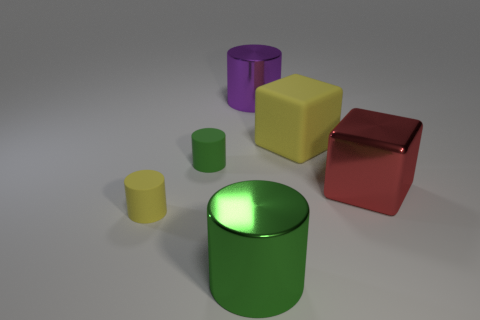Can you tell which material the objects might be made of? Based on their shiny surfaces and reflections, the objects appear to be made of a polished, reflective material, likely metal or plastic. Could you store liquid in any of these shapes? The cylinder would be best suited to hold liquid due to its enclosed circular shape with no openings. 